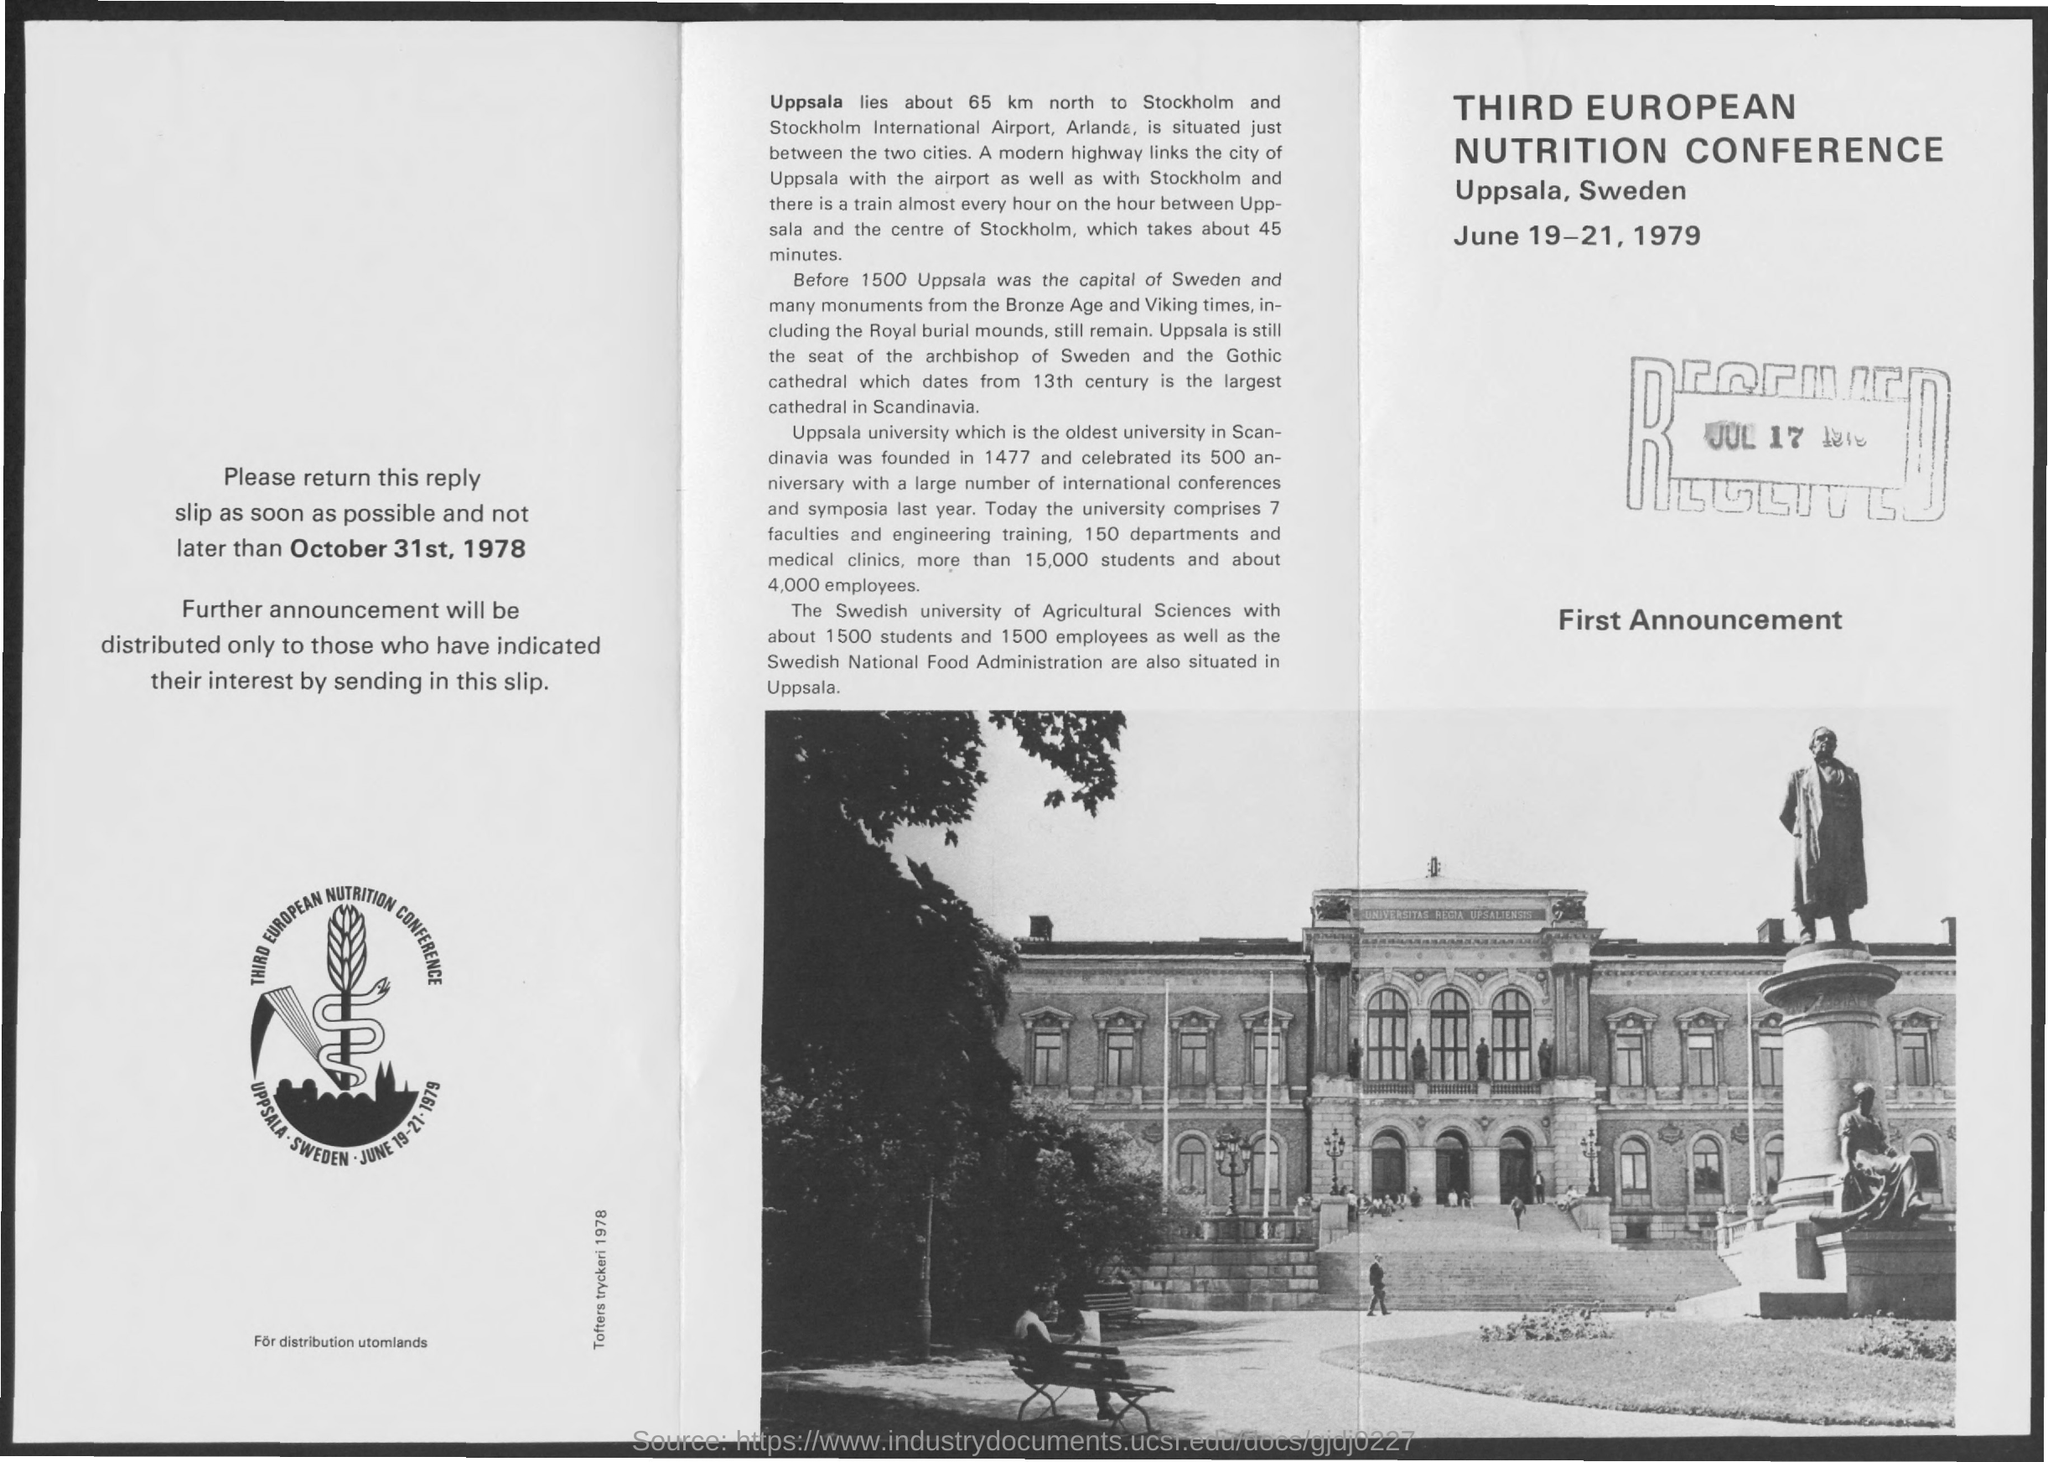Third European Nutrition Conference is held at ?
Provide a succinct answer. Uppsala, Sweden. When was third european nutrition confernce held on?
Provide a succinct answer. JUNE 19-21, 1979. 